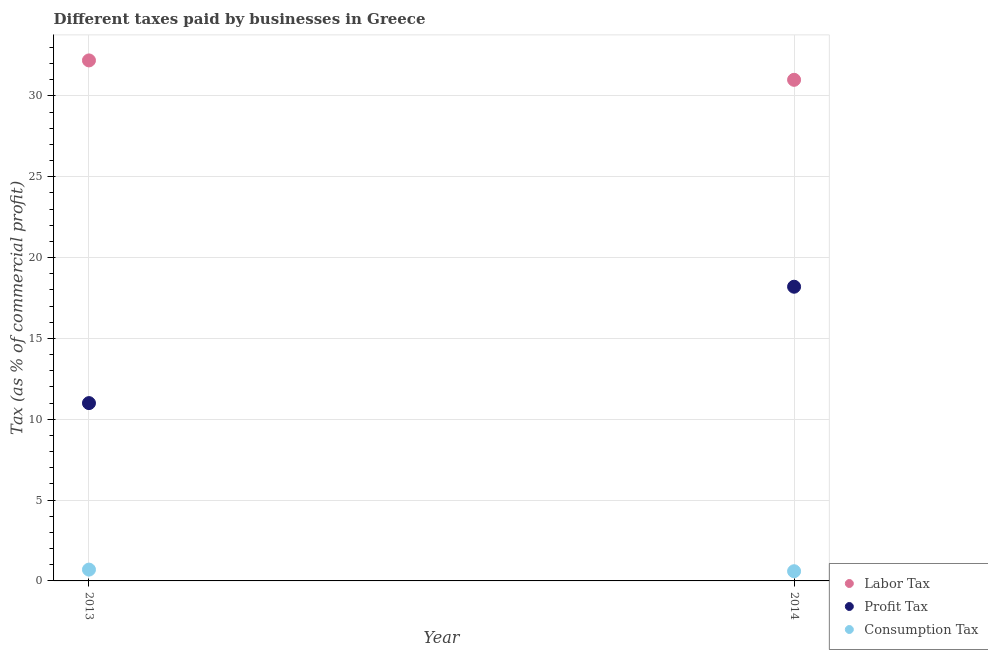Is the number of dotlines equal to the number of legend labels?
Give a very brief answer. Yes. Across all years, what is the maximum percentage of profit tax?
Keep it short and to the point. 18.2. What is the total percentage of profit tax in the graph?
Give a very brief answer. 29.2. What is the difference between the percentage of labor tax in 2013 and that in 2014?
Keep it short and to the point. 1.2. In the year 2014, what is the difference between the percentage of profit tax and percentage of consumption tax?
Your answer should be compact. 17.6. In how many years, is the percentage of consumption tax greater than 32 %?
Provide a short and direct response. 0. What is the ratio of the percentage of consumption tax in 2013 to that in 2014?
Offer a terse response. 1.17. Is the percentage of profit tax strictly less than the percentage of labor tax over the years?
Provide a short and direct response. Yes. How many dotlines are there?
Your answer should be compact. 3. How many years are there in the graph?
Offer a very short reply. 2. What is the difference between two consecutive major ticks on the Y-axis?
Offer a terse response. 5. Does the graph contain any zero values?
Give a very brief answer. No. Where does the legend appear in the graph?
Provide a succinct answer. Bottom right. How many legend labels are there?
Give a very brief answer. 3. What is the title of the graph?
Provide a short and direct response. Different taxes paid by businesses in Greece. What is the label or title of the Y-axis?
Provide a short and direct response. Tax (as % of commercial profit). What is the Tax (as % of commercial profit) in Labor Tax in 2013?
Offer a terse response. 32.2. What is the Tax (as % of commercial profit) in Profit Tax in 2013?
Your response must be concise. 11. What is the Tax (as % of commercial profit) in Consumption Tax in 2014?
Offer a terse response. 0.6. Across all years, what is the maximum Tax (as % of commercial profit) in Labor Tax?
Your answer should be very brief. 32.2. Across all years, what is the minimum Tax (as % of commercial profit) in Labor Tax?
Offer a terse response. 31. Across all years, what is the minimum Tax (as % of commercial profit) of Profit Tax?
Your answer should be compact. 11. Across all years, what is the minimum Tax (as % of commercial profit) in Consumption Tax?
Your answer should be very brief. 0.6. What is the total Tax (as % of commercial profit) in Labor Tax in the graph?
Provide a short and direct response. 63.2. What is the total Tax (as % of commercial profit) of Profit Tax in the graph?
Offer a very short reply. 29.2. What is the total Tax (as % of commercial profit) in Consumption Tax in the graph?
Provide a succinct answer. 1.3. What is the difference between the Tax (as % of commercial profit) of Profit Tax in 2013 and that in 2014?
Provide a succinct answer. -7.2. What is the difference between the Tax (as % of commercial profit) of Consumption Tax in 2013 and that in 2014?
Your response must be concise. 0.1. What is the difference between the Tax (as % of commercial profit) of Labor Tax in 2013 and the Tax (as % of commercial profit) of Consumption Tax in 2014?
Your response must be concise. 31.6. What is the difference between the Tax (as % of commercial profit) in Profit Tax in 2013 and the Tax (as % of commercial profit) in Consumption Tax in 2014?
Give a very brief answer. 10.4. What is the average Tax (as % of commercial profit) of Labor Tax per year?
Give a very brief answer. 31.6. What is the average Tax (as % of commercial profit) of Profit Tax per year?
Provide a succinct answer. 14.6. What is the average Tax (as % of commercial profit) in Consumption Tax per year?
Offer a terse response. 0.65. In the year 2013, what is the difference between the Tax (as % of commercial profit) in Labor Tax and Tax (as % of commercial profit) in Profit Tax?
Make the answer very short. 21.2. In the year 2013, what is the difference between the Tax (as % of commercial profit) of Labor Tax and Tax (as % of commercial profit) of Consumption Tax?
Make the answer very short. 31.5. In the year 2014, what is the difference between the Tax (as % of commercial profit) in Labor Tax and Tax (as % of commercial profit) in Profit Tax?
Offer a very short reply. 12.8. In the year 2014, what is the difference between the Tax (as % of commercial profit) in Labor Tax and Tax (as % of commercial profit) in Consumption Tax?
Provide a succinct answer. 30.4. What is the ratio of the Tax (as % of commercial profit) in Labor Tax in 2013 to that in 2014?
Offer a very short reply. 1.04. What is the ratio of the Tax (as % of commercial profit) in Profit Tax in 2013 to that in 2014?
Offer a terse response. 0.6. What is the difference between the highest and the second highest Tax (as % of commercial profit) of Consumption Tax?
Your answer should be compact. 0.1. What is the difference between the highest and the lowest Tax (as % of commercial profit) of Consumption Tax?
Your response must be concise. 0.1. 